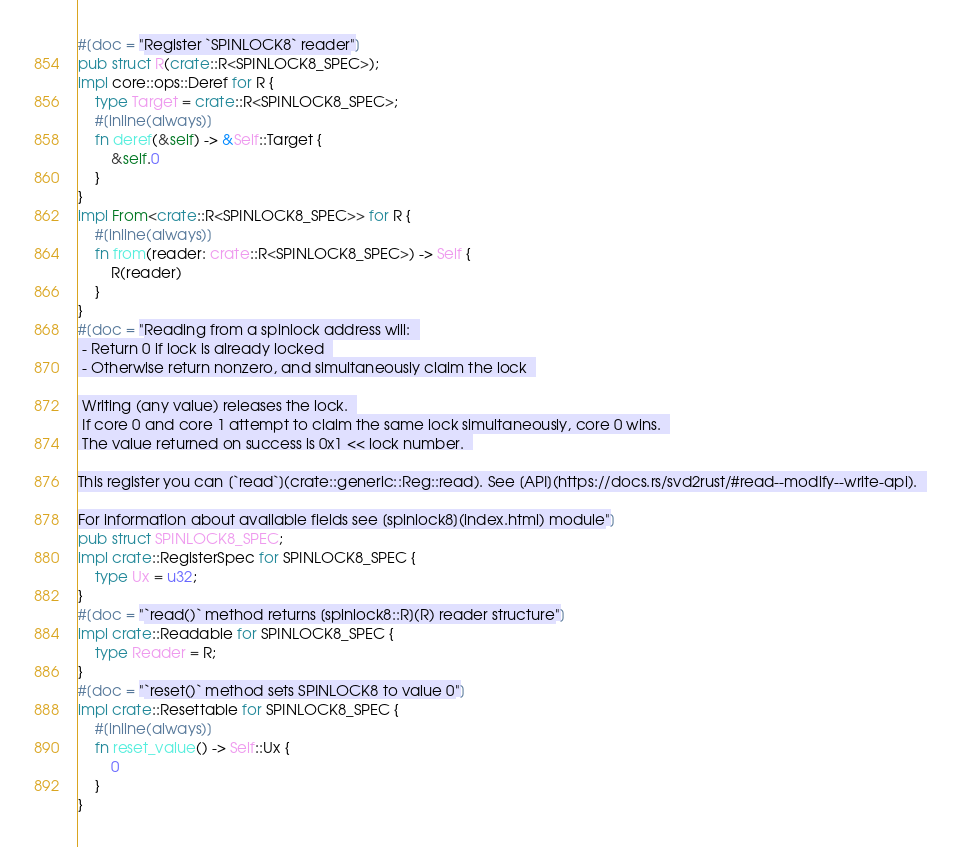<code> <loc_0><loc_0><loc_500><loc_500><_Rust_>#[doc = "Register `SPINLOCK8` reader"]
pub struct R(crate::R<SPINLOCK8_SPEC>);
impl core::ops::Deref for R {
    type Target = crate::R<SPINLOCK8_SPEC>;
    #[inline(always)]
    fn deref(&self) -> &Self::Target {
        &self.0
    }
}
impl From<crate::R<SPINLOCK8_SPEC>> for R {
    #[inline(always)]
    fn from(reader: crate::R<SPINLOCK8_SPEC>) -> Self {
        R(reader)
    }
}
#[doc = "Reading from a spinlock address will:  
 - Return 0 if lock is already locked  
 - Otherwise return nonzero, and simultaneously claim the lock  

 Writing (any value) releases the lock.  
 If core 0 and core 1 attempt to claim the same lock simultaneously, core 0 wins.  
 The value returned on success is 0x1 << lock number.  

This register you can [`read`](crate::generic::Reg::read). See [API](https://docs.rs/svd2rust/#read--modify--write-api).  

For information about available fields see [spinlock8](index.html) module"]
pub struct SPINLOCK8_SPEC;
impl crate::RegisterSpec for SPINLOCK8_SPEC {
    type Ux = u32;
}
#[doc = "`read()` method returns [spinlock8::R](R) reader structure"]
impl crate::Readable for SPINLOCK8_SPEC {
    type Reader = R;
}
#[doc = "`reset()` method sets SPINLOCK8 to value 0"]
impl crate::Resettable for SPINLOCK8_SPEC {
    #[inline(always)]
    fn reset_value() -> Self::Ux {
        0
    }
}
</code> 